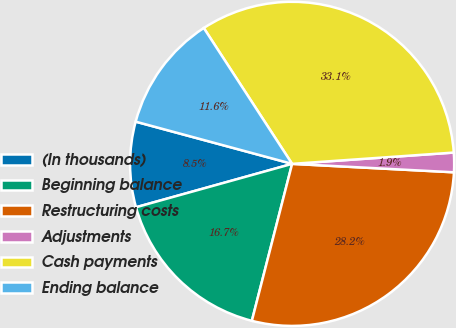Convert chart. <chart><loc_0><loc_0><loc_500><loc_500><pie_chart><fcel>(In thousands)<fcel>Beginning balance<fcel>Restructuring costs<fcel>Adjustments<fcel>Cash payments<fcel>Ending balance<nl><fcel>8.51%<fcel>16.69%<fcel>28.17%<fcel>1.94%<fcel>33.07%<fcel>11.63%<nl></chart> 